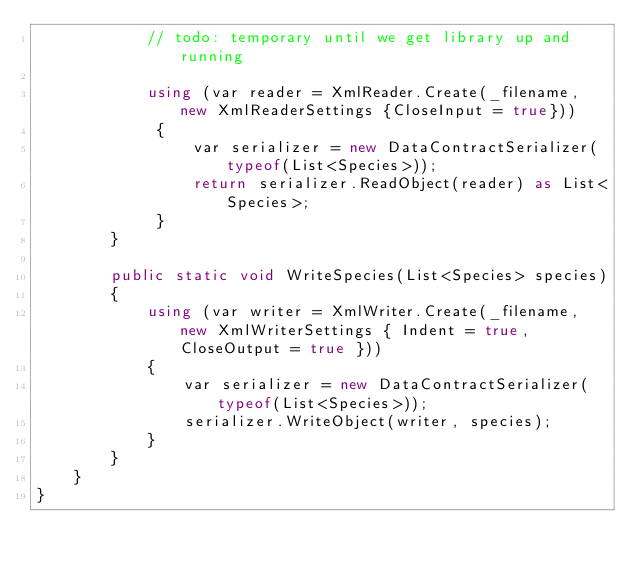Convert code to text. <code><loc_0><loc_0><loc_500><loc_500><_C#_>            // todo: temporary until we get library up and running

            using (var reader = XmlReader.Create(_filename, new XmlReaderSettings {CloseInput = true}))
             {
                 var serializer = new DataContractSerializer(typeof(List<Species>));
                 return serializer.ReadObject(reader) as List<Species>;
             }
        }

        public static void WriteSpecies(List<Species> species)
        {
            using (var writer = XmlWriter.Create(_filename, new XmlWriterSettings { Indent = true, CloseOutput = true }))
            {
                var serializer = new DataContractSerializer(typeof(List<Species>));
                serializer.WriteObject(writer, species);
            }
        }
    }
}</code> 